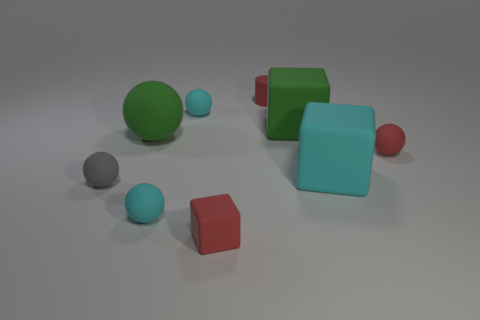Is there any indication about the texture of the surfaces that these objects are resting on? The surface on which the objects rest appears to be matte with a slight roughness, as indicated by the soft shadows that contour around the bases of the objects. This texture likely provides some grip, preventing the spherical objects from rolling away. 